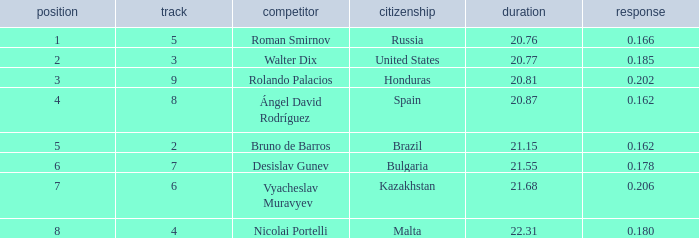What's Russia's lane when they were ranked before 1? None. 